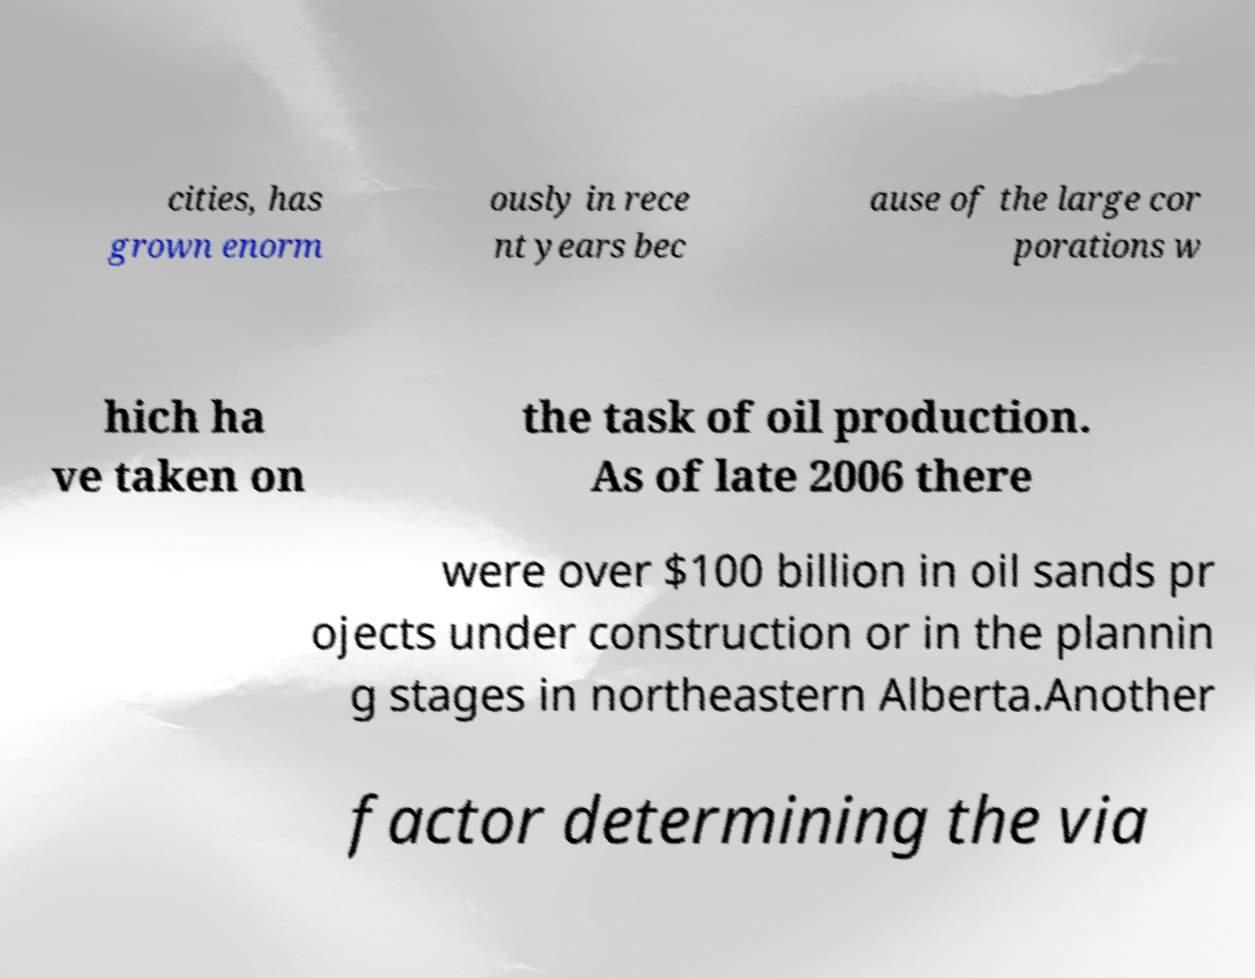Can you accurately transcribe the text from the provided image for me? cities, has grown enorm ously in rece nt years bec ause of the large cor porations w hich ha ve taken on the task of oil production. As of late 2006 there were over $100 billion in oil sands pr ojects under construction or in the plannin g stages in northeastern Alberta.Another factor determining the via 